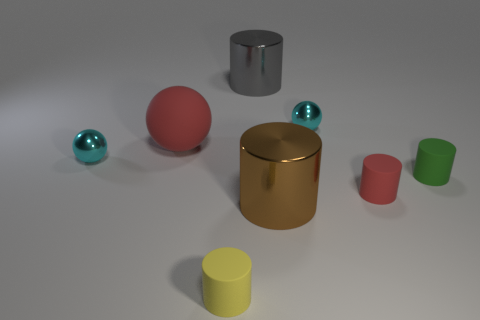Subtract all red cylinders. How many cylinders are left? 4 Subtract all tiny yellow cylinders. How many cylinders are left? 4 Subtract all blue cylinders. Subtract all red spheres. How many cylinders are left? 5 Add 1 big brown cylinders. How many objects exist? 9 Subtract all spheres. How many objects are left? 5 Subtract all large brown metal cylinders. Subtract all tiny purple metal cylinders. How many objects are left? 7 Add 5 small yellow rubber things. How many small yellow rubber things are left? 6 Add 3 tiny yellow rubber blocks. How many tiny yellow rubber blocks exist? 3 Subtract 1 gray cylinders. How many objects are left? 7 